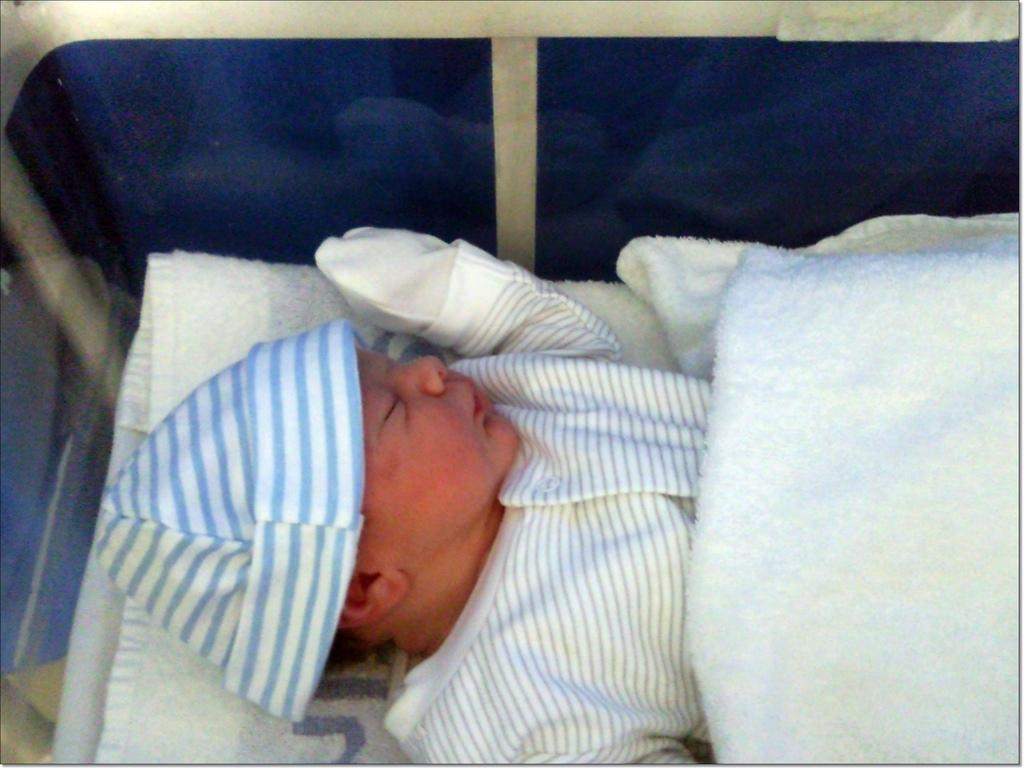What is the main subject of the image? There is a baby in the image. What is the baby doing in the image? The baby is sleeping. What type of clothing is the baby wearing on their upper body? The baby is wearing a t-shirt. What type of headwear is the baby wearing? The baby is wearing a cap. What type of handwear is the baby wearing? The baby is wearing hand gloves. What type of chess piece is the baby holding in the image? There is no chess piece present in the image. What type of fruit is the baby eating in the image? There is no fruit present in the image. 